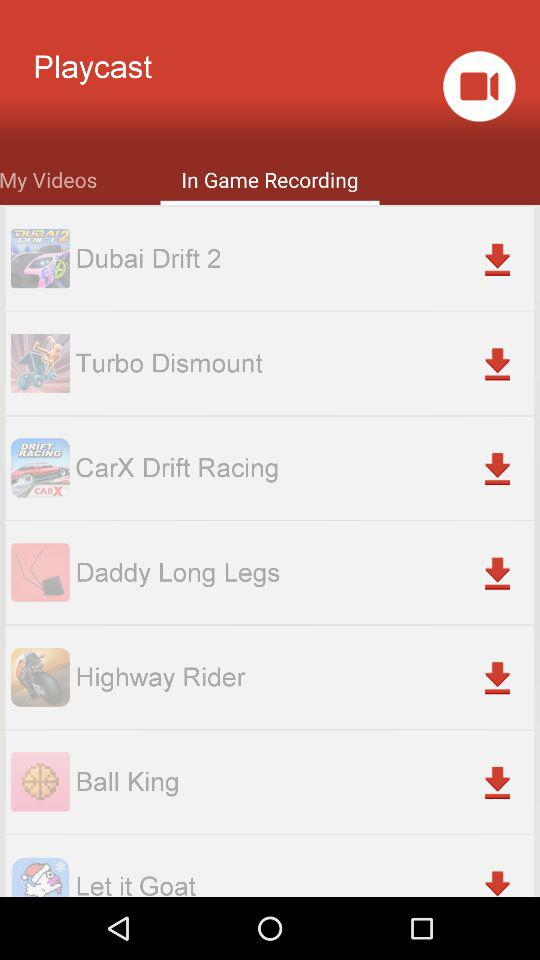Which tab is selected? The selected tab is "In Game Recording". 